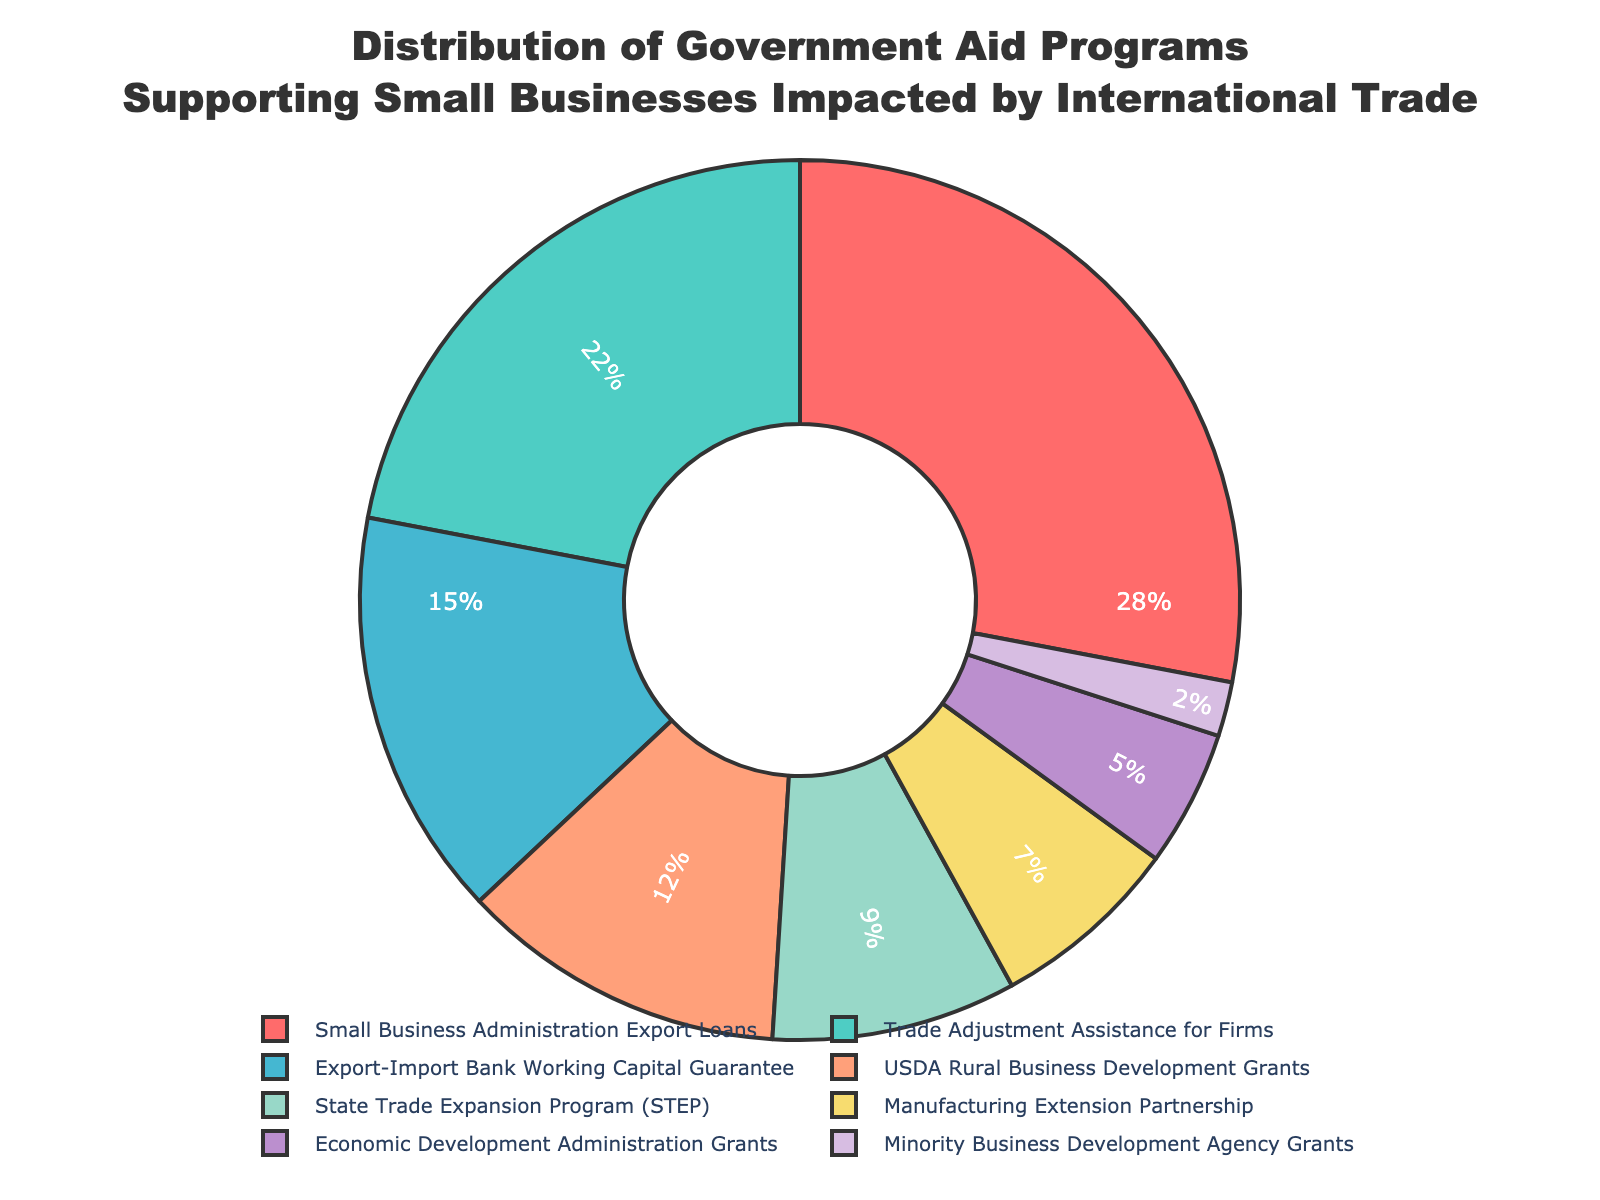What's the largest government aid program supporting small businesses impacted by international trade? The figure shows the "Small Business Administration Export Loans" with the largest segment, indicating it's the largest aid program at 28%.
Answer: Small Business Administration Export Loans Which program receives the least percentage of government aid? According to the figure, the "Minority Business Development Agency Grants" segment is the smallest, comprising 2% of the aid.
Answer: Minority Business Development Agency Grants How much more percentage does the "Small Business Administration Export Loans" receive compared to the "Trade Adjustment Assistance for Firms"? "Small Business Administration Export Loans" has 28% and "Trade Adjustment Assistance for Firms" has 22%. The difference is calculated as 28% - 22% = 6%.
Answer: 6% Which programs have percentages less than 10%? The segments representing "State Trade Expansion Program (STEP)", "Manufacturing Extension Partnership", "Economic Development Administration Grants", and "Minority Business Development Agency Grants" are all less than 10%.
Answer: State Trade Expansion Program (STEP), Manufacturing Extension Partnership, Economic Development Administration Grants, Minority Business Development Agency Grants How many different aid programs have been identified in the pie chart? The pie chart visually represents segments for all the listed aid programs, which count to 8 distinct aid programs.
Answer: 8 What is the combined percentage of the "USDA Rural Business Development Grants" and the "State Trade Expansion Program (STEP)"? The chart shows "USDA Rural Business Development Grants" at 12% and "State Trade Expansion Program (STEP)" at 9%. Adding these gives 12% + 9% = 21%.
Answer: 21% Which program is represented by the light green color in the chart? Observing the chart, the light green segment refers to "Trade Adjustment Assistance for Firms".
Answer: Trade Adjustment Assistance for Firms What is the total percentage of the three smallest aid programs? The figure shows the percentages for "Economic Development Administration Grants" (5%), "Manufacturing Extension Partnership" (7%), and "Minority Business Development Agency Grants" (2%). Summing these percentages, we get 5% + 7% + 2% = 14%.
Answer: 14% 